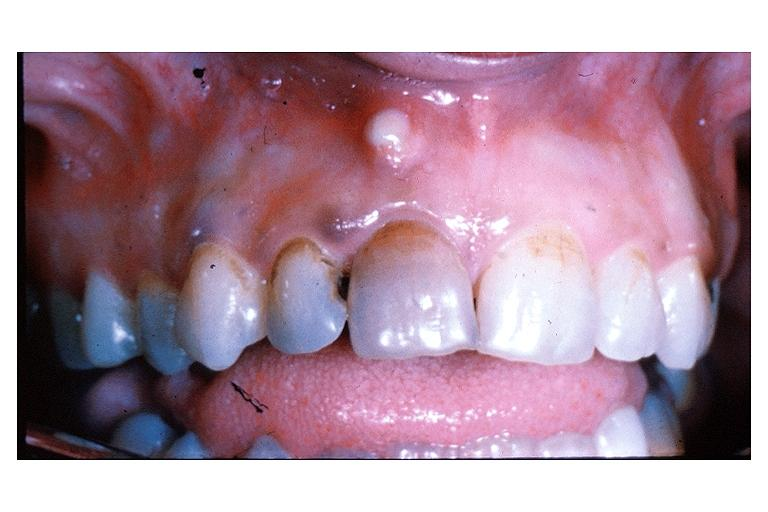does odontoid process subluxation with narrowing of foramen magnum show parulis acute alveolar abscess?
Answer the question using a single word or phrase. No 